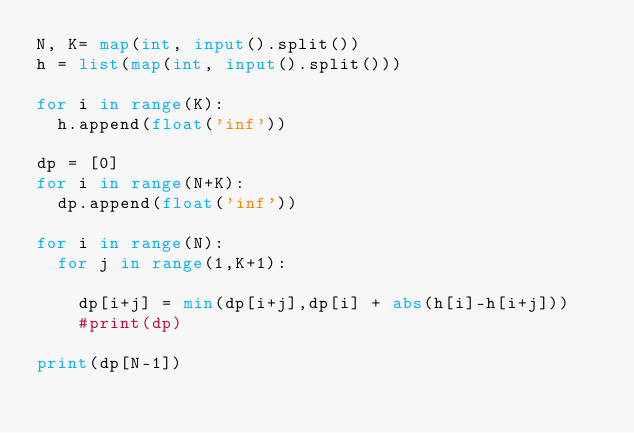<code> <loc_0><loc_0><loc_500><loc_500><_Python_>N, K= map(int, input().split())
h = list(map(int, input().split()))

for i in range(K):
  h.append(float('inf'))

dp = [0]
for i in range(N+K):
  dp.append(float('inf'))

for i in range(N):
  for j in range(1,K+1):
    
    dp[i+j] = min(dp[i+j],dp[i] + abs(h[i]-h[i+j]))
    #print(dp)

print(dp[N-1])</code> 